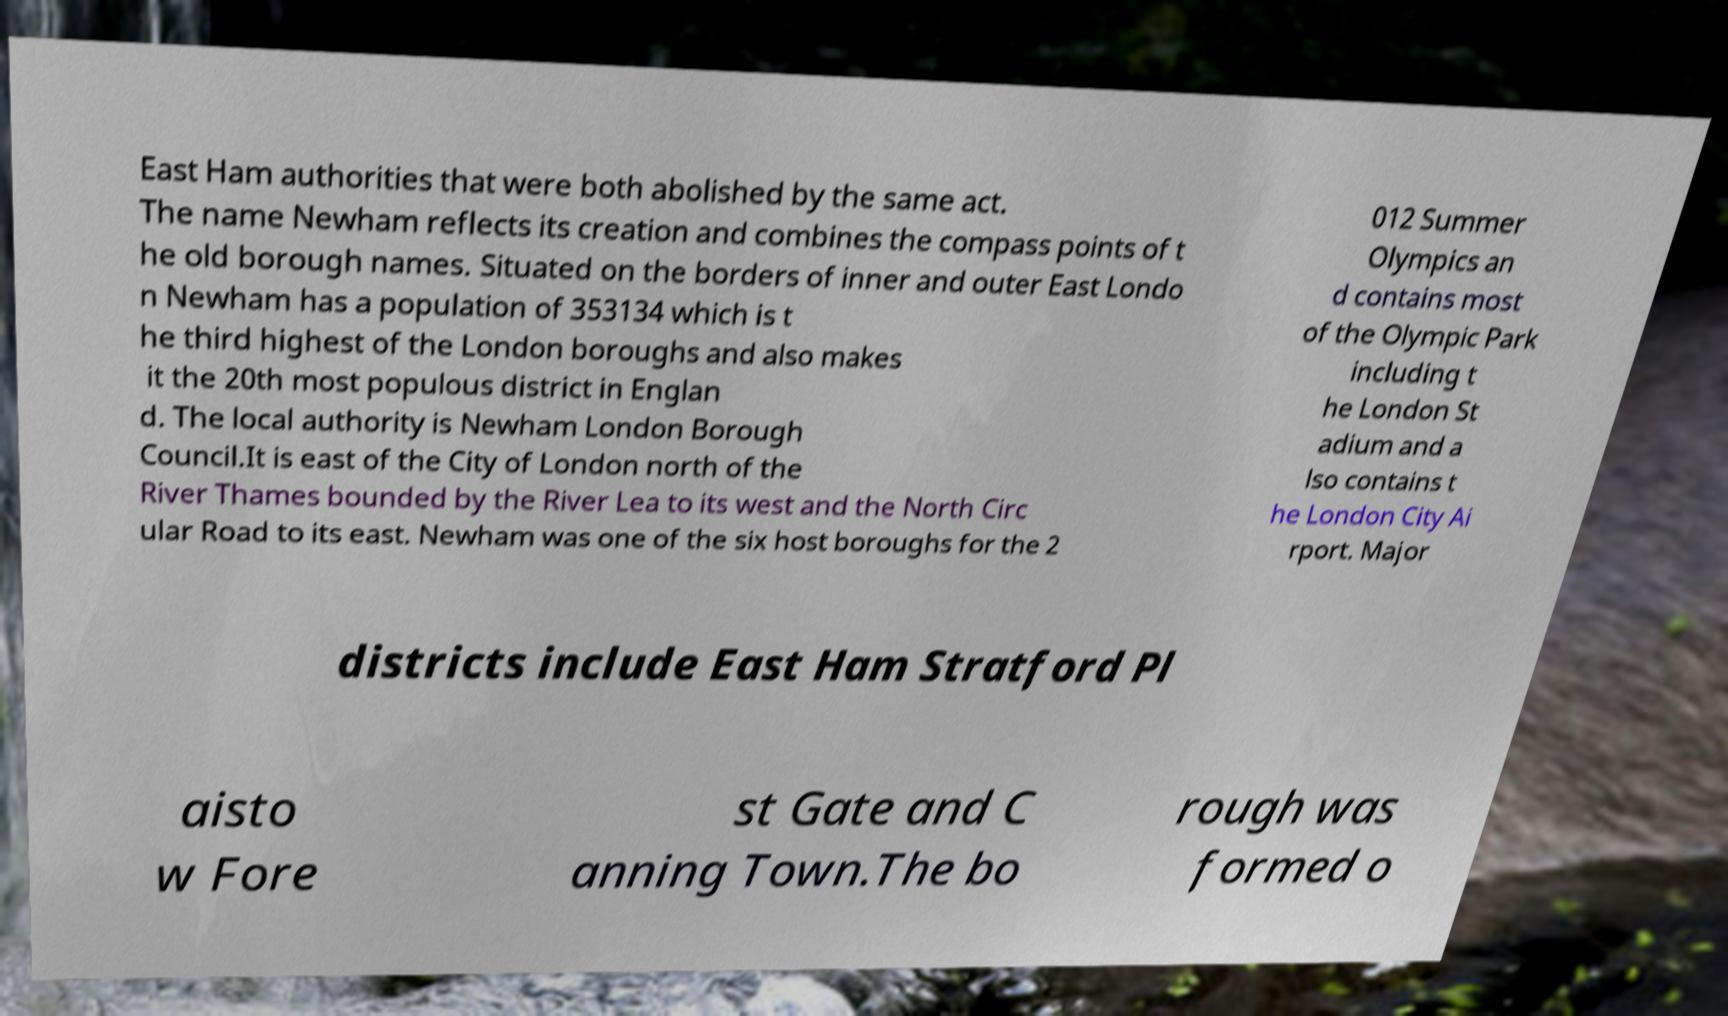Can you accurately transcribe the text from the provided image for me? East Ham authorities that were both abolished by the same act. The name Newham reflects its creation and combines the compass points of t he old borough names. Situated on the borders of inner and outer East Londo n Newham has a population of 353134 which is t he third highest of the London boroughs and also makes it the 20th most populous district in Englan d. The local authority is Newham London Borough Council.It is east of the City of London north of the River Thames bounded by the River Lea to its west and the North Circ ular Road to its east. Newham was one of the six host boroughs for the 2 012 Summer Olympics an d contains most of the Olympic Park including t he London St adium and a lso contains t he London City Ai rport. Major districts include East Ham Stratford Pl aisto w Fore st Gate and C anning Town.The bo rough was formed o 